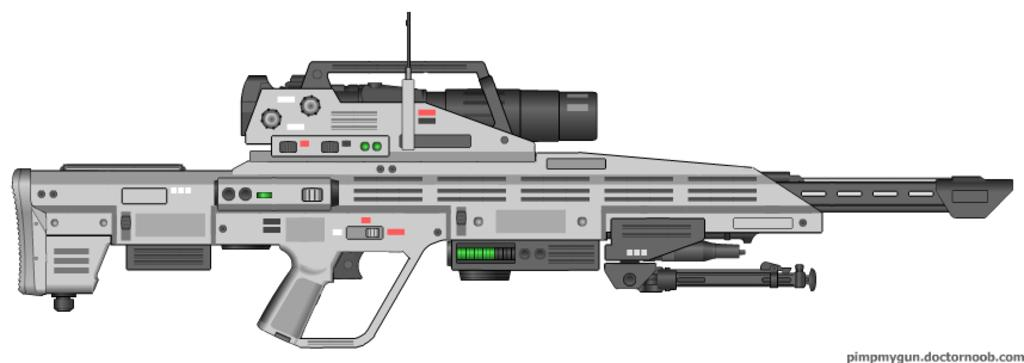What is the main object in the image? There is a rifle in the image. What color is the background of the image? The background of the image is white. Where can text be found in the image? There is text in the bottom right corner of the image. What type of wren is perched on the rifle in the image? There is no wren present in the image; it only features a rifle and a white background. What message does the text in the image convey as someone says good-bye? The image does not depict a good-bye scene, and there is no context provided for the text in the image. 